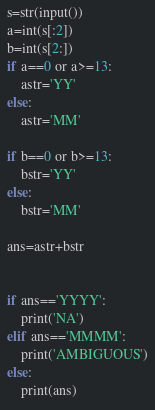Convert code to text. <code><loc_0><loc_0><loc_500><loc_500><_Python_>s=str(input())
a=int(s[:2])
b=int(s[2:])
if a==0 or a>=13:
    astr='YY'
else:
    astr='MM'

if b==0 or b>=13:
    bstr='YY'
else:
    bstr='MM'

ans=astr+bstr


if ans=='YYYY':
    print('NA')
elif ans=='MMMM':
    print('AMBIGUOUS')
else:
    print(ans)</code> 